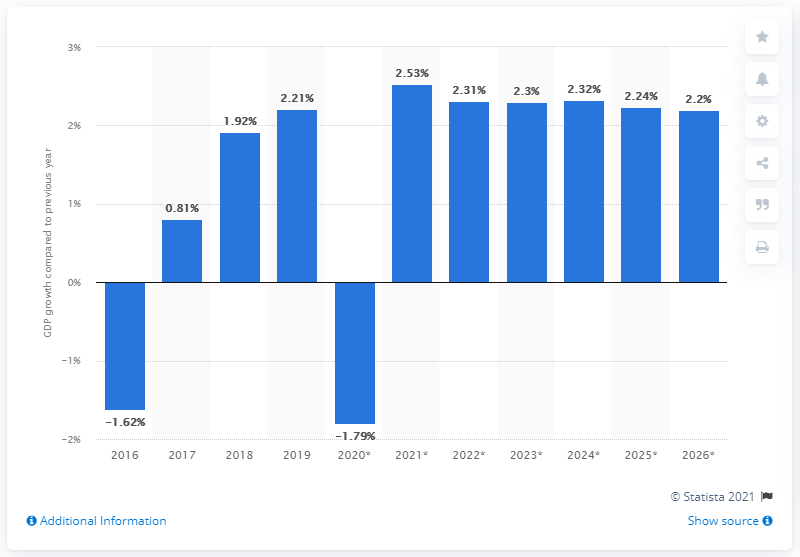Indicate a few pertinent items in this graphic. Nigeria's real gross domestic product increased by 2.2% in 2019. 